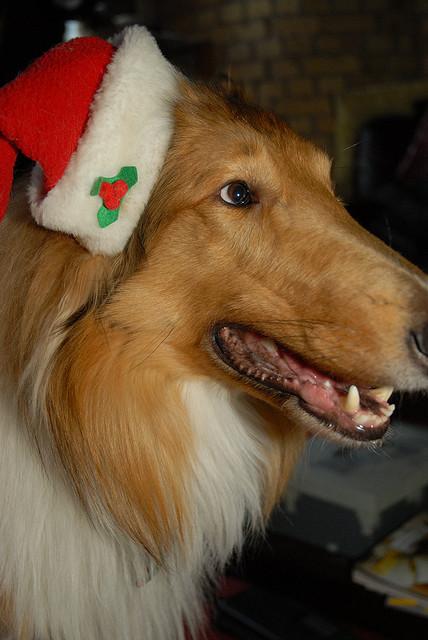What kind of dog is this?
Write a very short answer. Collie. What type of dog is this?
Concise answer only. Collie. What season is indicated by the dogs hat?
Give a very brief answer. Christmas. Why doesn't the dog close his mouth?
Keep it brief. Panting. What is the breed of dog?
Be succinct. Collie. Is the dog dressed as a Santa Claus?
Give a very brief answer. Yes. What breed is the dog?
Concise answer only. Collie. What color is the dog?
Quick response, please. Brown and white. 